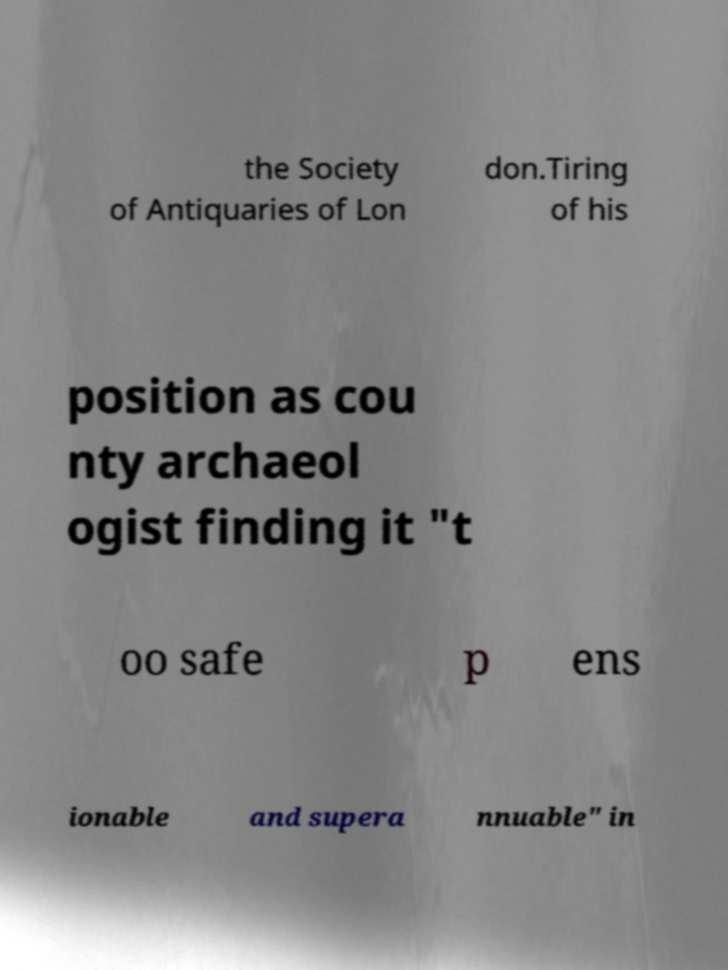Could you assist in decoding the text presented in this image and type it out clearly? the Society of Antiquaries of Lon don.Tiring of his position as cou nty archaeol ogist finding it "t oo safe p ens ionable and supera nnuable" in 